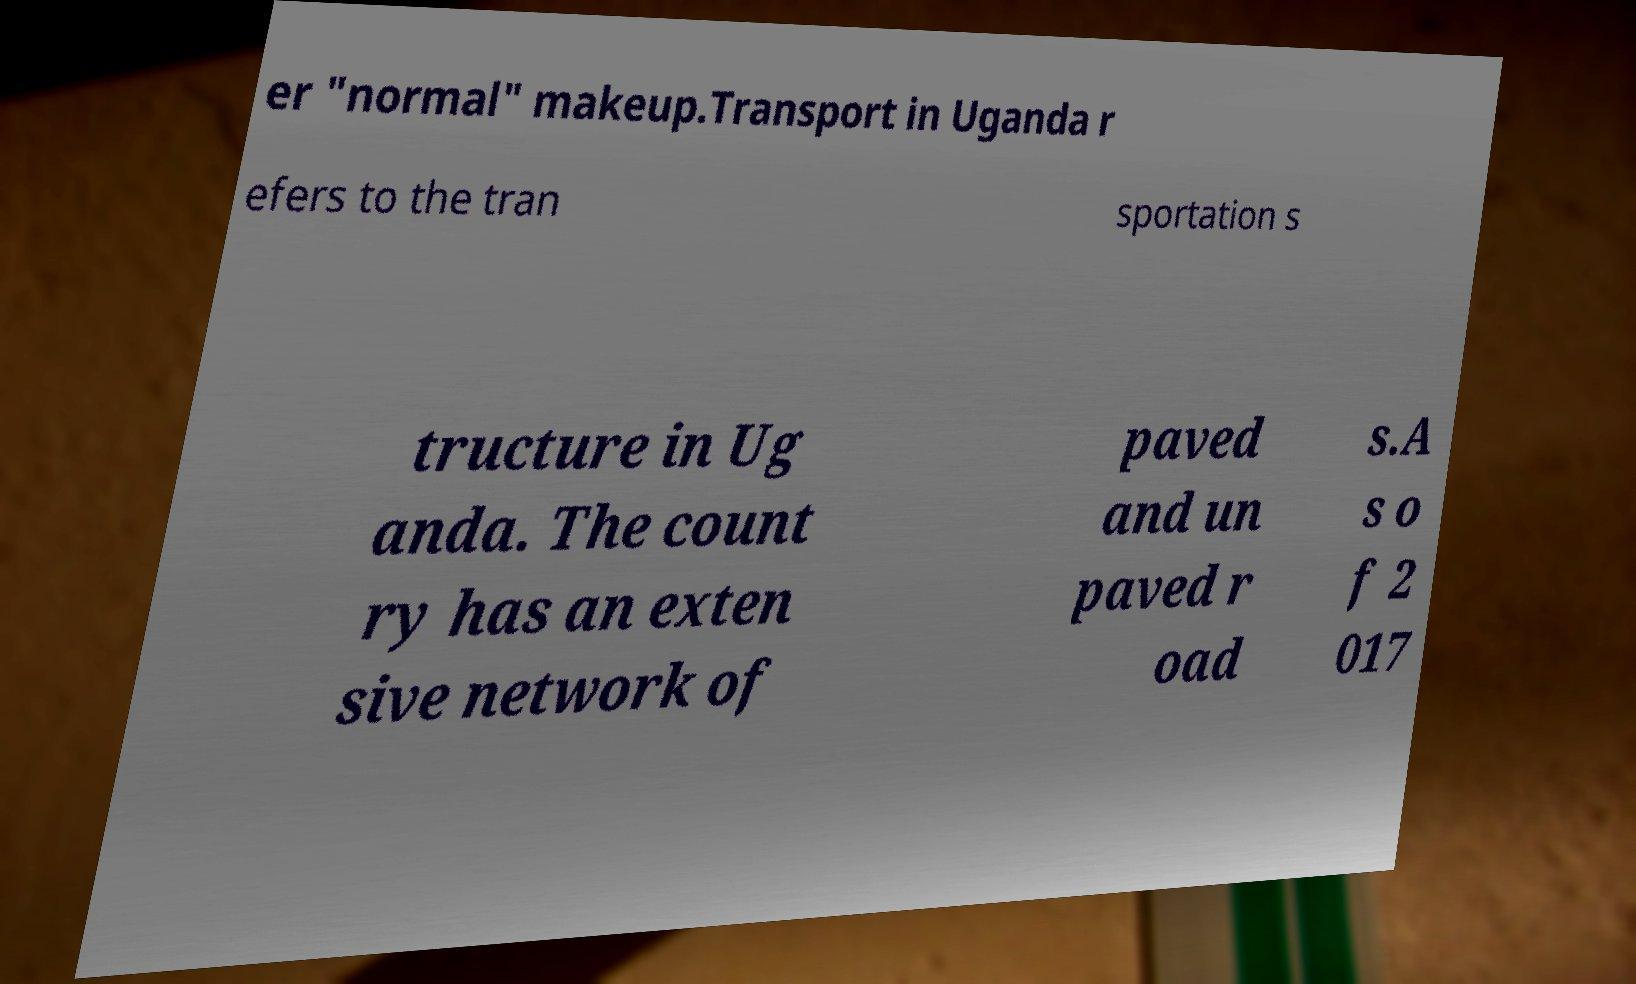There's text embedded in this image that I need extracted. Can you transcribe it verbatim? er "normal" makeup.Transport in Uganda r efers to the tran sportation s tructure in Ug anda. The count ry has an exten sive network of paved and un paved r oad s.A s o f 2 017 